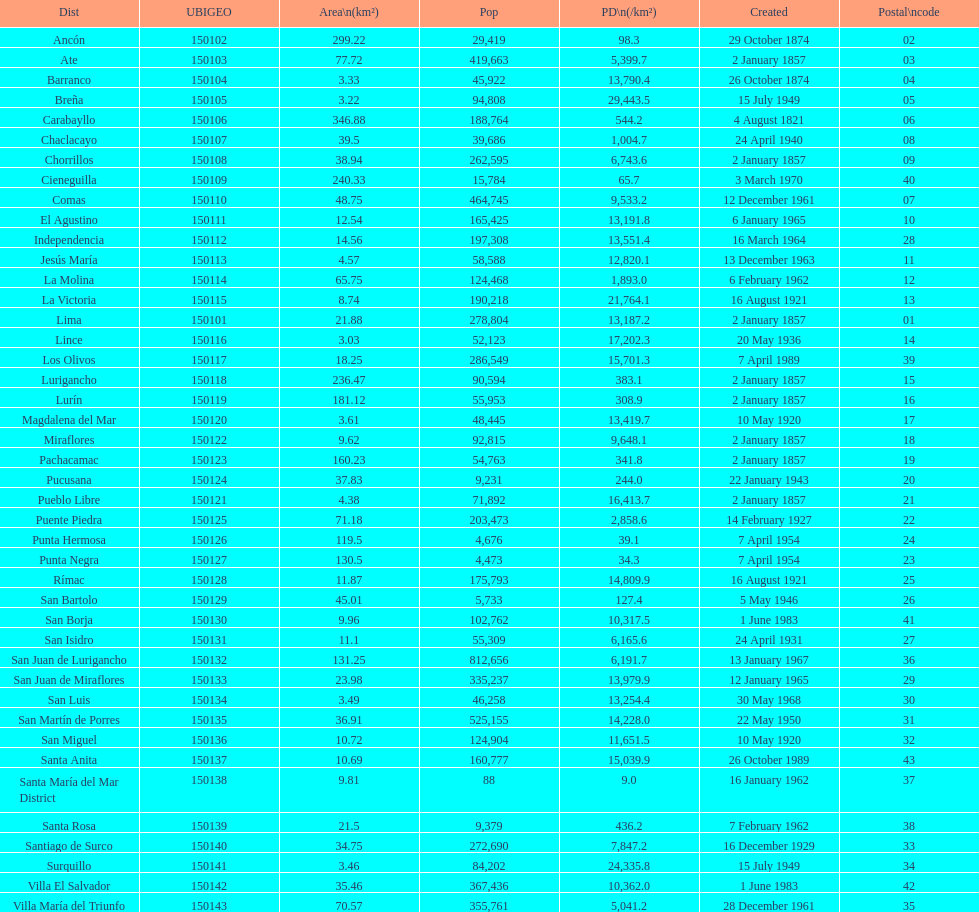Help me parse the entirety of this table. {'header': ['Dist', 'UBIGEO', 'Area\\n(km²)', 'Pop', 'PD\\n(/km²)', 'Created', 'Postal\\ncode'], 'rows': [['Ancón', '150102', '299.22', '29,419', '98.3', '29 October 1874', '02'], ['Ate', '150103', '77.72', '419,663', '5,399.7', '2 January 1857', '03'], ['Barranco', '150104', '3.33', '45,922', '13,790.4', '26 October 1874', '04'], ['Breña', '150105', '3.22', '94,808', '29,443.5', '15 July 1949', '05'], ['Carabayllo', '150106', '346.88', '188,764', '544.2', '4 August 1821', '06'], ['Chaclacayo', '150107', '39.5', '39,686', '1,004.7', '24 April 1940', '08'], ['Chorrillos', '150108', '38.94', '262,595', '6,743.6', '2 January 1857', '09'], ['Cieneguilla', '150109', '240.33', '15,784', '65.7', '3 March 1970', '40'], ['Comas', '150110', '48.75', '464,745', '9,533.2', '12 December 1961', '07'], ['El Agustino', '150111', '12.54', '165,425', '13,191.8', '6 January 1965', '10'], ['Independencia', '150112', '14.56', '197,308', '13,551.4', '16 March 1964', '28'], ['Jesús María', '150113', '4.57', '58,588', '12,820.1', '13 December 1963', '11'], ['La Molina', '150114', '65.75', '124,468', '1,893.0', '6 February 1962', '12'], ['La Victoria', '150115', '8.74', '190,218', '21,764.1', '16 August 1921', '13'], ['Lima', '150101', '21.88', '278,804', '13,187.2', '2 January 1857', '01'], ['Lince', '150116', '3.03', '52,123', '17,202.3', '20 May 1936', '14'], ['Los Olivos', '150117', '18.25', '286,549', '15,701.3', '7 April 1989', '39'], ['Lurigancho', '150118', '236.47', '90,594', '383.1', '2 January 1857', '15'], ['Lurín', '150119', '181.12', '55,953', '308.9', '2 January 1857', '16'], ['Magdalena del Mar', '150120', '3.61', '48,445', '13,419.7', '10 May 1920', '17'], ['Miraflores', '150122', '9.62', '92,815', '9,648.1', '2 January 1857', '18'], ['Pachacamac', '150123', '160.23', '54,763', '341.8', '2 January 1857', '19'], ['Pucusana', '150124', '37.83', '9,231', '244.0', '22 January 1943', '20'], ['Pueblo Libre', '150121', '4.38', '71,892', '16,413.7', '2 January 1857', '21'], ['Puente Piedra', '150125', '71.18', '203,473', '2,858.6', '14 February 1927', '22'], ['Punta Hermosa', '150126', '119.5', '4,676', '39.1', '7 April 1954', '24'], ['Punta Negra', '150127', '130.5', '4,473', '34.3', '7 April 1954', '23'], ['Rímac', '150128', '11.87', '175,793', '14,809.9', '16 August 1921', '25'], ['San Bartolo', '150129', '45.01', '5,733', '127.4', '5 May 1946', '26'], ['San Borja', '150130', '9.96', '102,762', '10,317.5', '1 June 1983', '41'], ['San Isidro', '150131', '11.1', '55,309', '6,165.6', '24 April 1931', '27'], ['San Juan de Lurigancho', '150132', '131.25', '812,656', '6,191.7', '13 January 1967', '36'], ['San Juan de Miraflores', '150133', '23.98', '335,237', '13,979.9', '12 January 1965', '29'], ['San Luis', '150134', '3.49', '46,258', '13,254.4', '30 May 1968', '30'], ['San Martín de Porres', '150135', '36.91', '525,155', '14,228.0', '22 May 1950', '31'], ['San Miguel', '150136', '10.72', '124,904', '11,651.5', '10 May 1920', '32'], ['Santa Anita', '150137', '10.69', '160,777', '15,039.9', '26 October 1989', '43'], ['Santa María del Mar District', '150138', '9.81', '88', '9.0', '16 January 1962', '37'], ['Santa Rosa', '150139', '21.5', '9,379', '436.2', '7 February 1962', '38'], ['Santiago de Surco', '150140', '34.75', '272,690', '7,847.2', '16 December 1929', '33'], ['Surquillo', '150141', '3.46', '84,202', '24,335.8', '15 July 1949', '34'], ['Villa El Salvador', '150142', '35.46', '367,436', '10,362.0', '1 June 1983', '42'], ['Villa María del Triunfo', '150143', '70.57', '355,761', '5,041.2', '28 December 1961', '35']]} What is the total number of districts created in the 1900's? 32. 